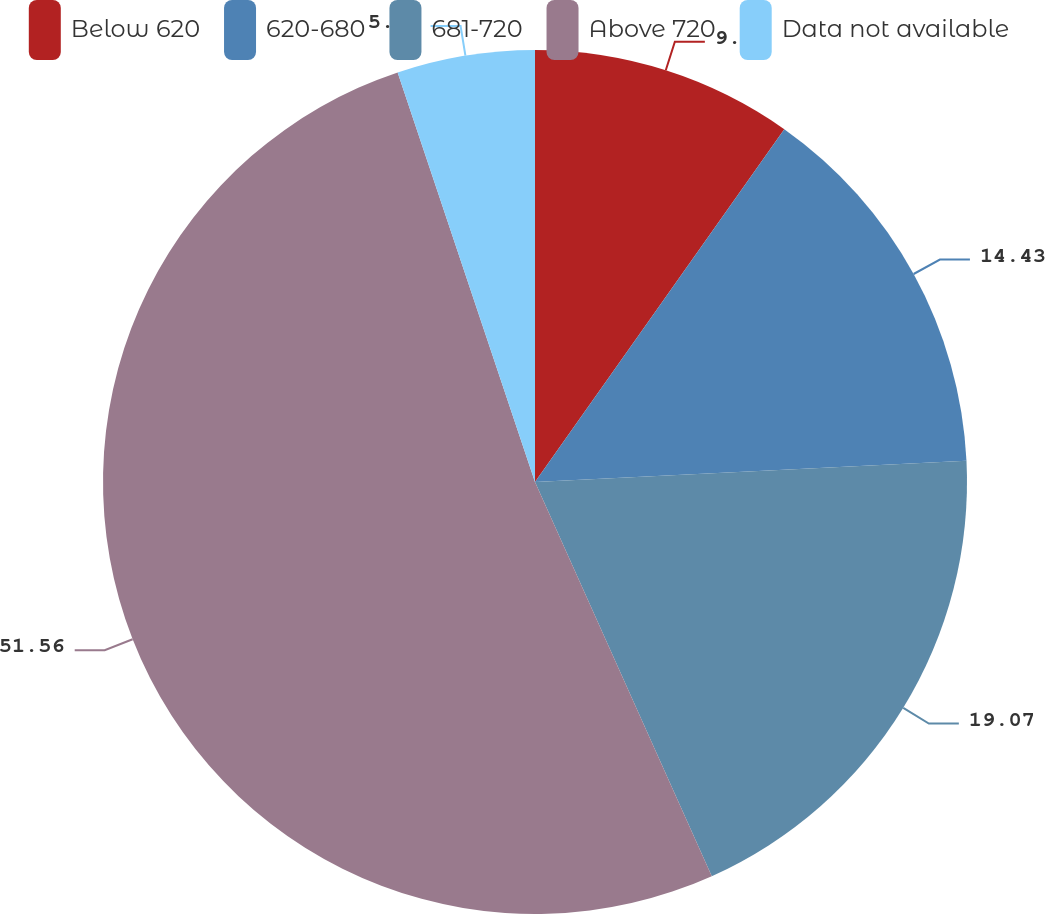<chart> <loc_0><loc_0><loc_500><loc_500><pie_chart><fcel>Below 620<fcel>620-680<fcel>681-720<fcel>Above 720<fcel>Data not available<nl><fcel>9.79%<fcel>14.43%<fcel>19.07%<fcel>51.56%<fcel>5.15%<nl></chart> 